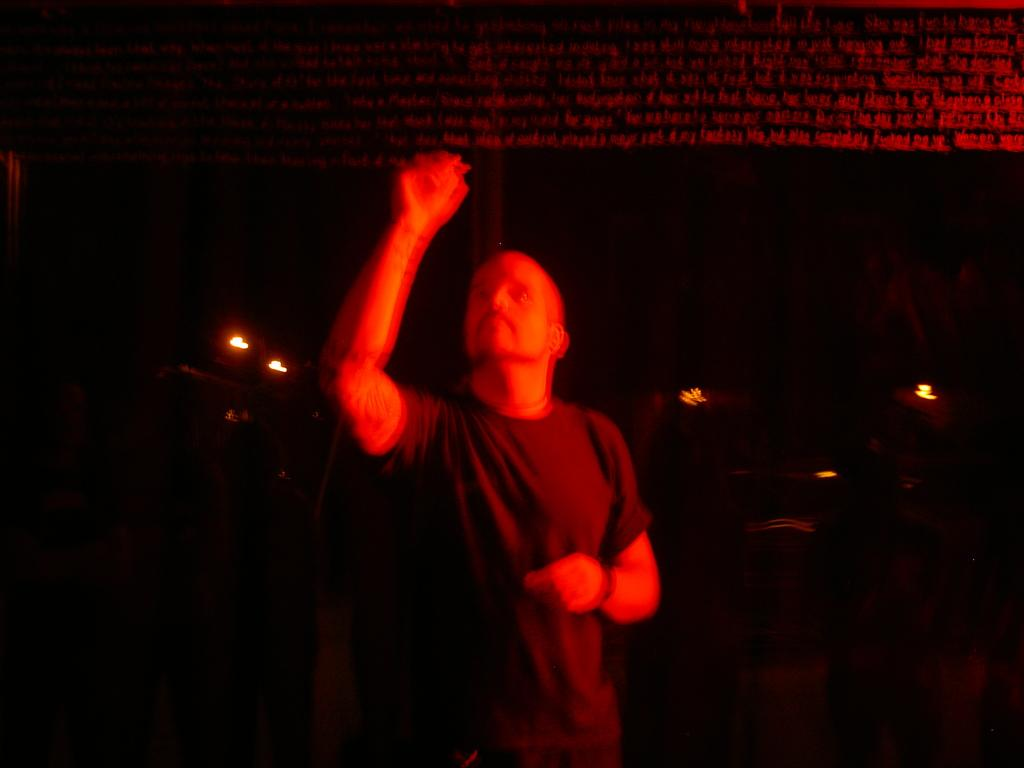What is the main subject of the image? There is a man in the image. Can you describe the man's surroundings? The man is standing in the dark. What is the man doing with his hand? The man is raising his hand. What color is the T-shirt the man is wearing? The man is wearing a black color T-shirt. How is the man illuminated in the image? The man is illuminated by a red color light. What type of sweater is the man wearing in the image? The man is not wearing a sweater in the image; he is wearing a black color T-shirt. Can you describe the man's head in the image? There is no specific detail about the man's head mentioned in the facts, so we cannot describe it. 